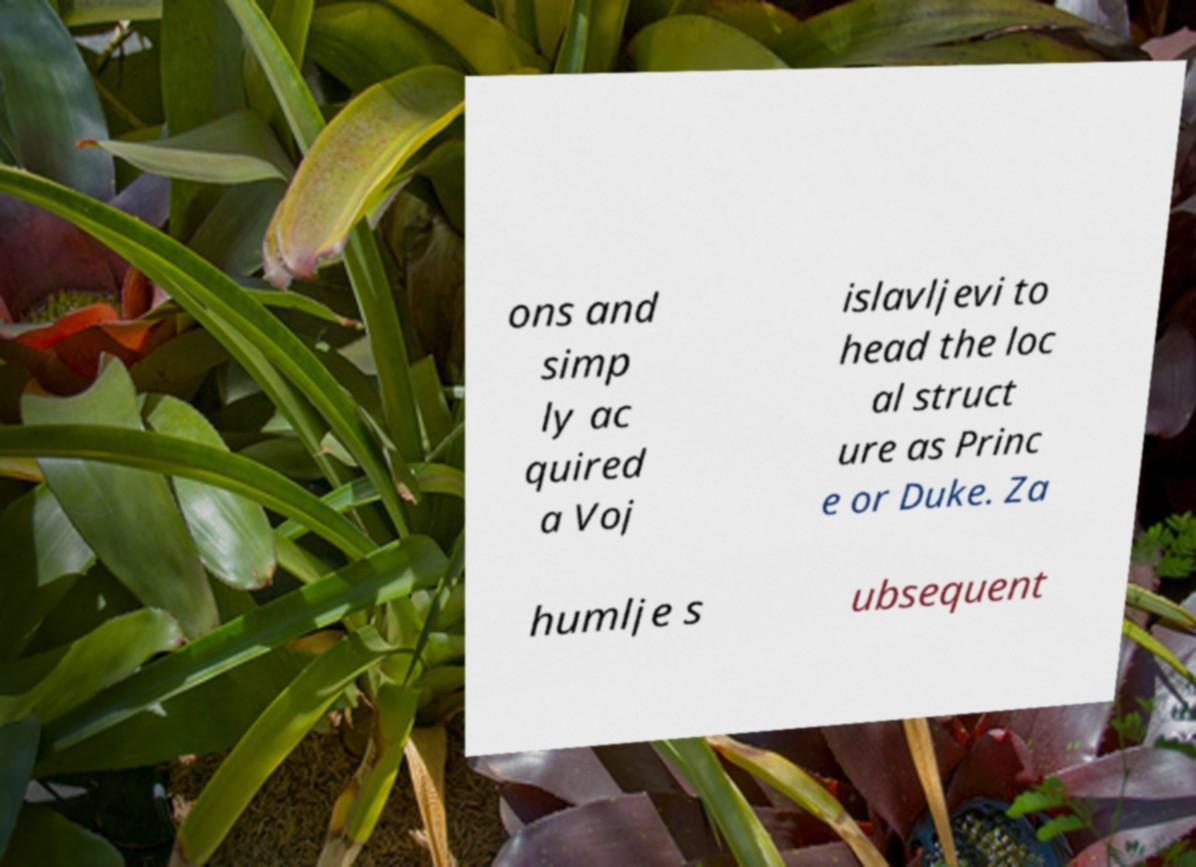Can you read and provide the text displayed in the image?This photo seems to have some interesting text. Can you extract and type it out for me? ons and simp ly ac quired a Voj islavljevi to head the loc al struct ure as Princ e or Duke. Za humlje s ubsequent 